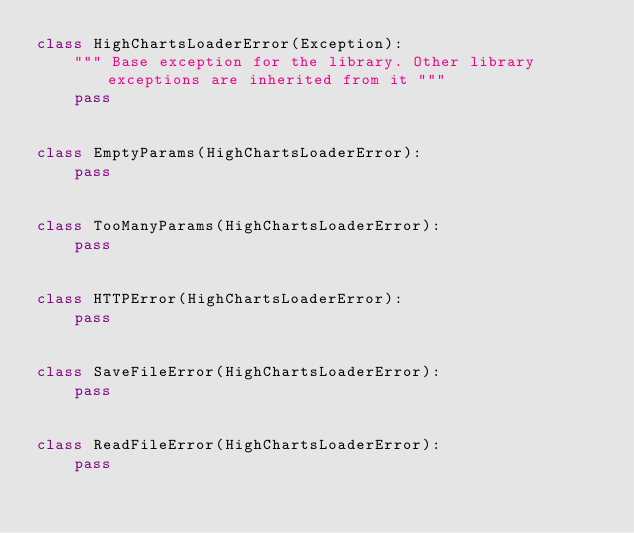<code> <loc_0><loc_0><loc_500><loc_500><_Python_>class HighChartsLoaderError(Exception):
    """ Base exception for the library. Other library exceptions are inherited from it """
    pass


class EmptyParams(HighChartsLoaderError):
    pass


class TooManyParams(HighChartsLoaderError):
    pass


class HTTPError(HighChartsLoaderError):
    pass


class SaveFileError(HighChartsLoaderError):
    pass


class ReadFileError(HighChartsLoaderError):
    pass
</code> 